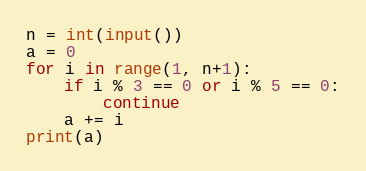Convert code to text. <code><loc_0><loc_0><loc_500><loc_500><_Python_>n = int(input())
a = 0
for i in range(1, n+1):
    if i % 3 == 0 or i % 5 == 0:
        continue
    a += i
print(a)</code> 